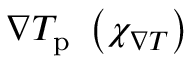Convert formula to latex. <formula><loc_0><loc_0><loc_500><loc_500>\nabla T _ { p } \, \left ( \chi _ { \nabla T } \right )</formula> 